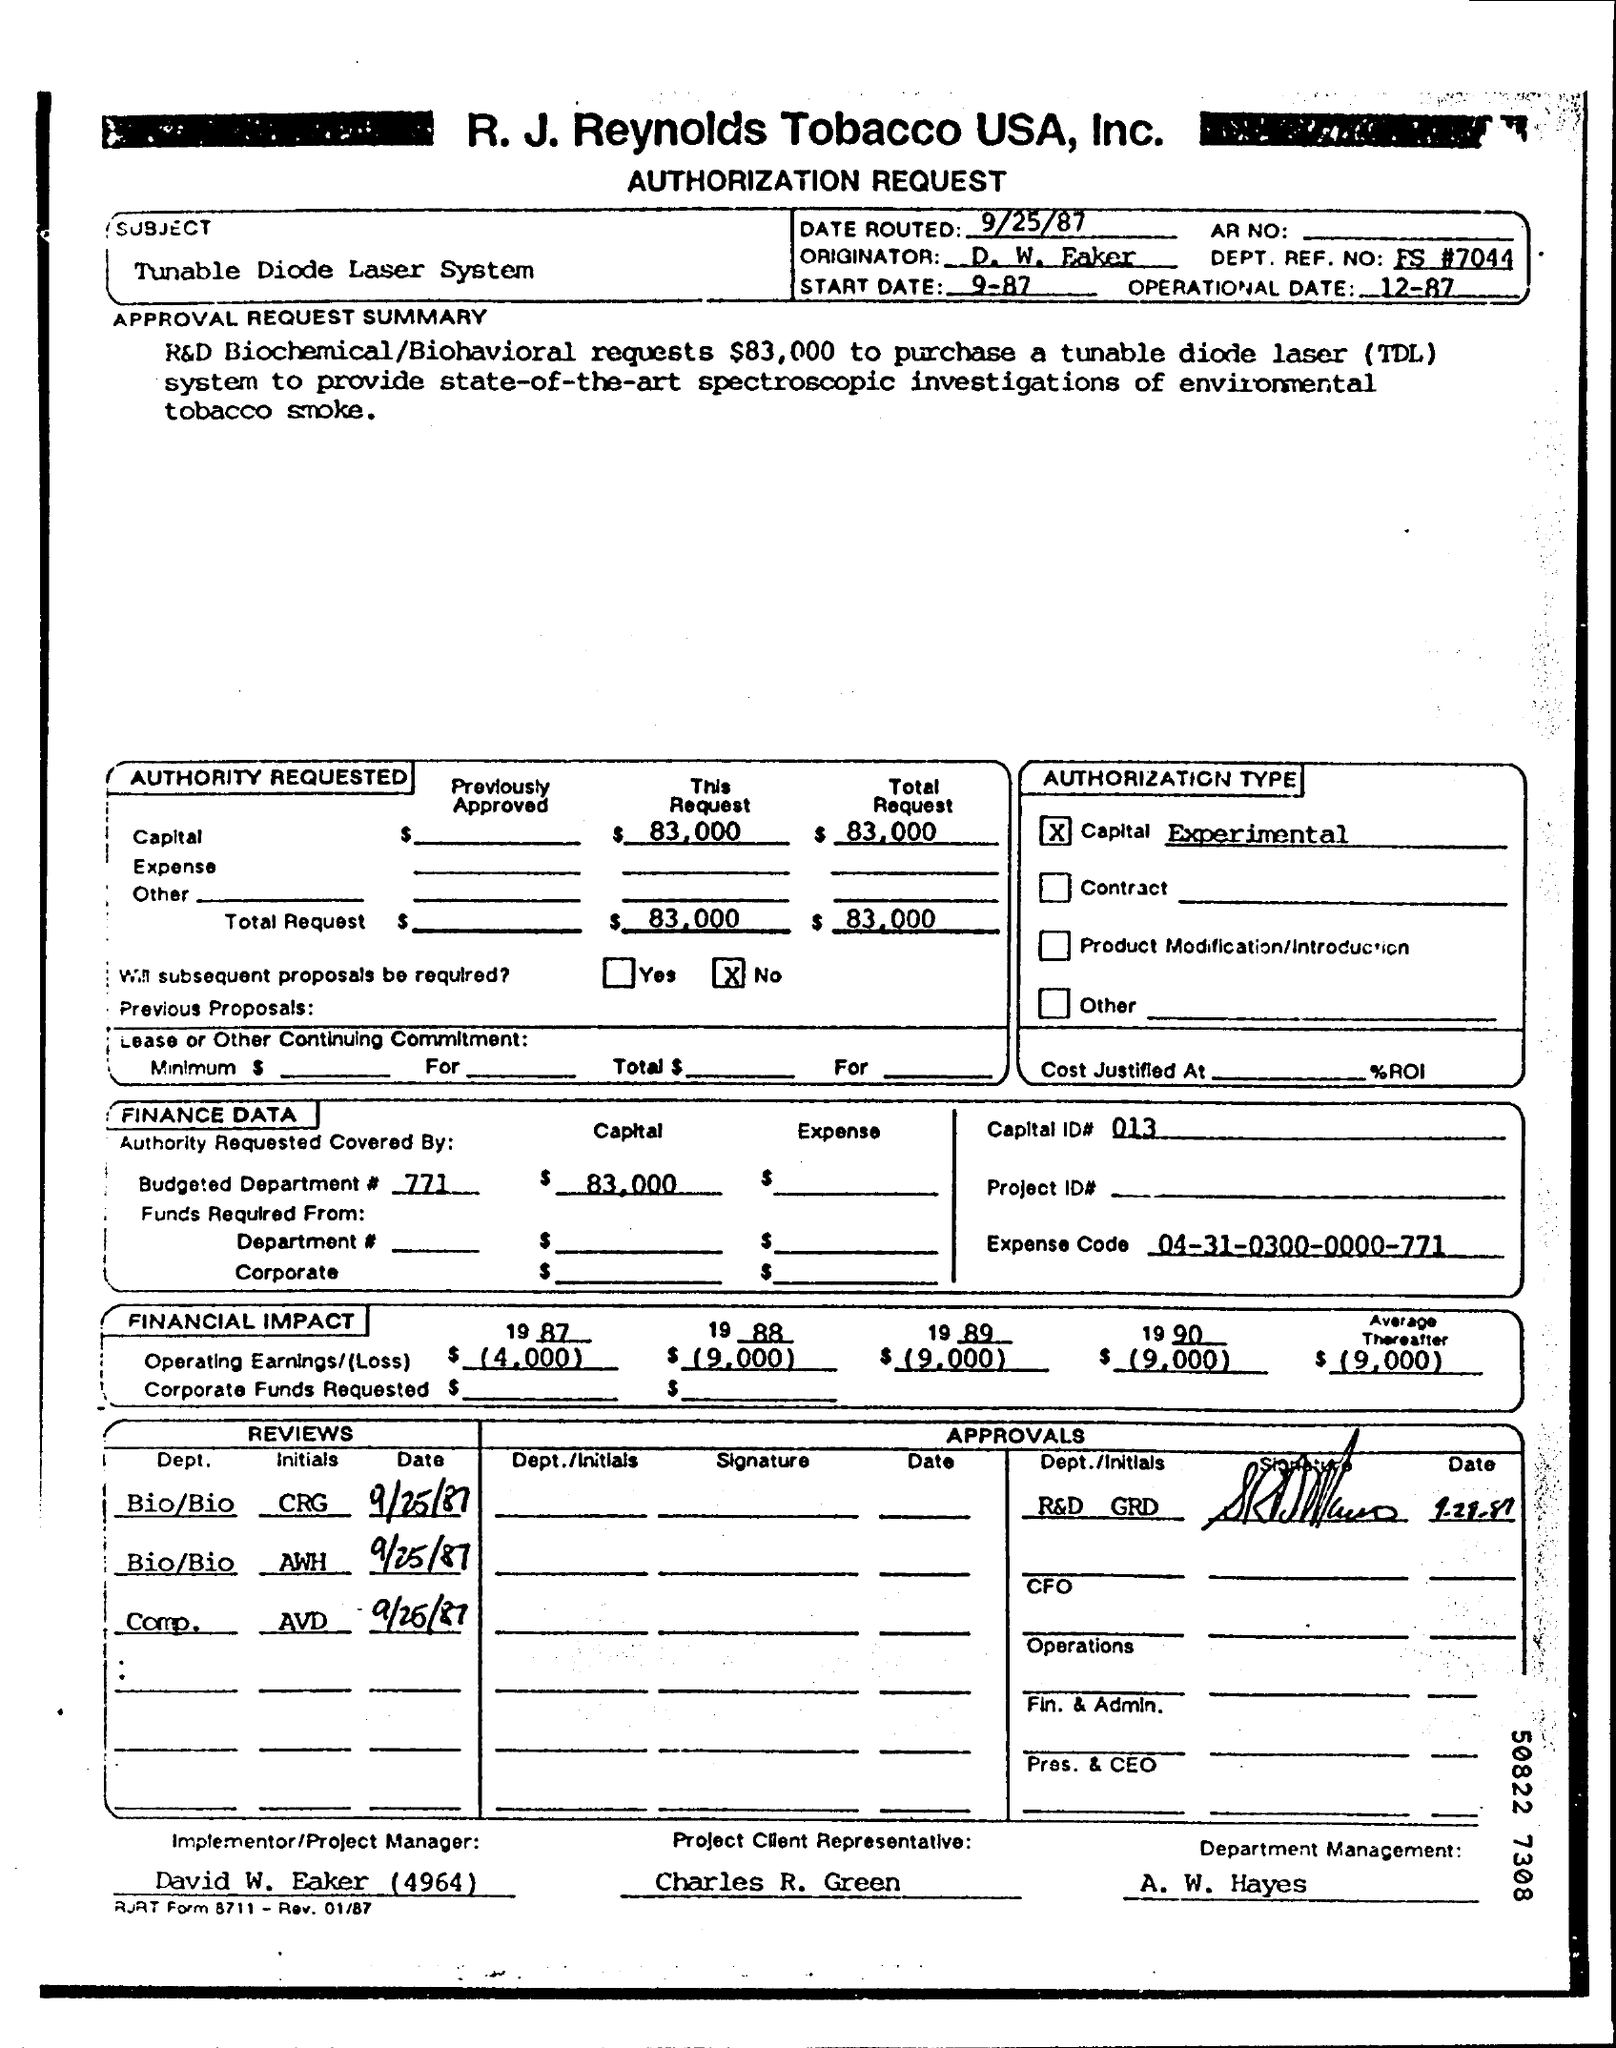What is the subject of the Authorization request ?
Offer a very short reply. Tunable Diode Laser system. What does TDL stand for ?
Provide a succinct answer. Tunable Diode Laser. What amount is requested to purchase a TDL ?
Offer a very short reply. $83,000. Who is the Project client Representative ?
Make the answer very short. Charles R. Green. What is the date routed ?
Your answer should be compact. 9/25/87. 